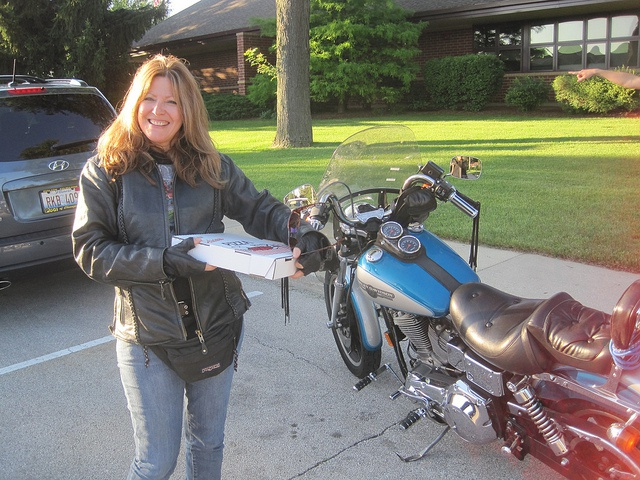Describe the objects in this image and their specific colors. I can see motorcycle in black, gray, darkgray, brown, and olive tones, people in black, gray, and ivory tones, car in black and gray tones, and handbag in black tones in this image. 